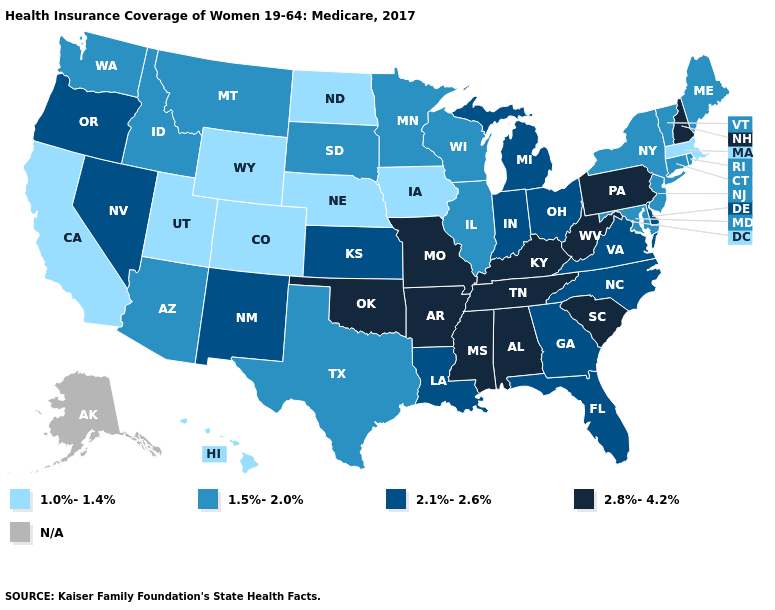Does the first symbol in the legend represent the smallest category?
Concise answer only. Yes. Name the states that have a value in the range 1.0%-1.4%?
Give a very brief answer. California, Colorado, Hawaii, Iowa, Massachusetts, Nebraska, North Dakota, Utah, Wyoming. What is the value of Florida?
Short answer required. 2.1%-2.6%. What is the value of Virginia?
Give a very brief answer. 2.1%-2.6%. Name the states that have a value in the range 1.0%-1.4%?
Quick response, please. California, Colorado, Hawaii, Iowa, Massachusetts, Nebraska, North Dakota, Utah, Wyoming. What is the lowest value in states that border Utah?
Answer briefly. 1.0%-1.4%. What is the value of Virginia?
Quick response, please. 2.1%-2.6%. Among the states that border Massachusetts , which have the highest value?
Short answer required. New Hampshire. Among the states that border Georgia , does North Carolina have the highest value?
Answer briefly. No. What is the value of New York?
Short answer required. 1.5%-2.0%. What is the highest value in states that border Wyoming?
Answer briefly. 1.5%-2.0%. Is the legend a continuous bar?
Keep it brief. No. Which states hav the highest value in the South?
Be succinct. Alabama, Arkansas, Kentucky, Mississippi, Oklahoma, South Carolina, Tennessee, West Virginia. What is the value of Maryland?
Short answer required. 1.5%-2.0%. What is the lowest value in states that border New Jersey?
Quick response, please. 1.5%-2.0%. 